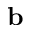<formula> <loc_0><loc_0><loc_500><loc_500>b</formula> 